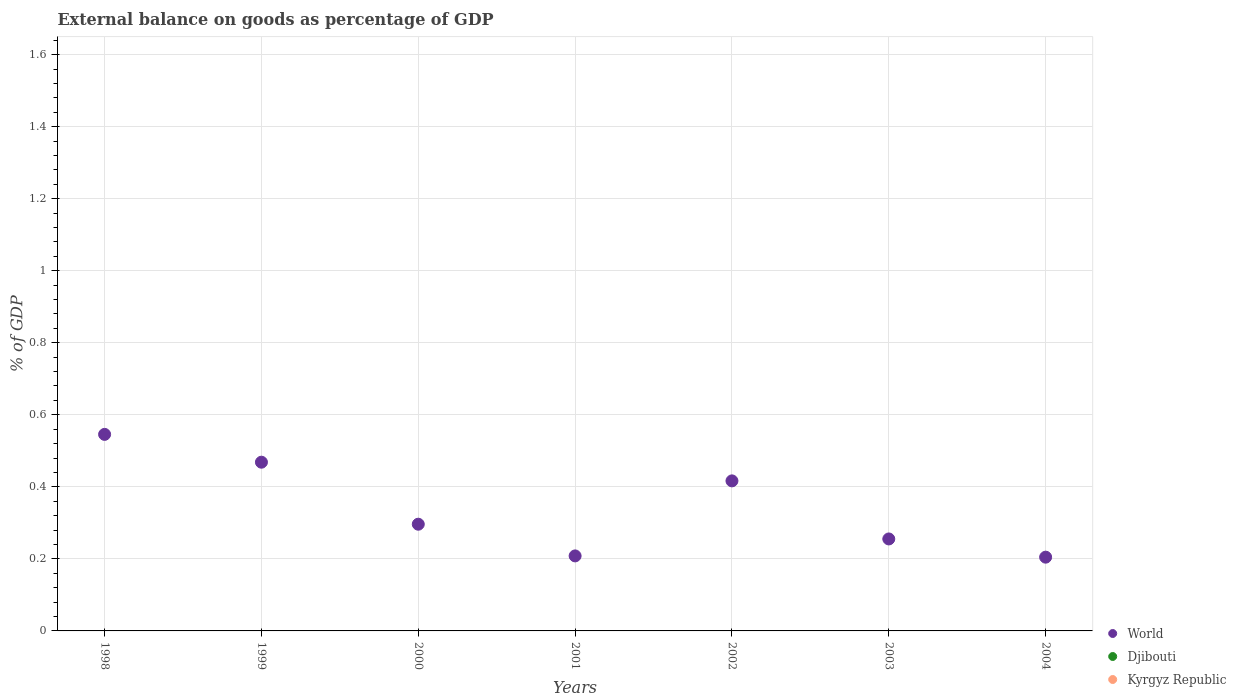How many different coloured dotlines are there?
Your answer should be very brief. 1. Is the number of dotlines equal to the number of legend labels?
Keep it short and to the point. No. What is the external balance on goods as percentage of GDP in World in 2003?
Your answer should be very brief. 0.26. Across all years, what is the maximum external balance on goods as percentage of GDP in World?
Give a very brief answer. 0.55. Across all years, what is the minimum external balance on goods as percentage of GDP in Kyrgyz Republic?
Provide a succinct answer. 0. What is the difference between the external balance on goods as percentage of GDP in World in 2002 and that in 2003?
Give a very brief answer. 0.16. What is the difference between the external balance on goods as percentage of GDP in Djibouti in 1998 and the external balance on goods as percentage of GDP in World in 2002?
Offer a very short reply. -0.42. What is the average external balance on goods as percentage of GDP in Kyrgyz Republic per year?
Provide a short and direct response. 0. In how many years, is the external balance on goods as percentage of GDP in World greater than 1.2400000000000002 %?
Offer a terse response. 0. What is the ratio of the external balance on goods as percentage of GDP in World in 1999 to that in 2003?
Give a very brief answer. 1.83. What is the difference between the highest and the second highest external balance on goods as percentage of GDP in World?
Ensure brevity in your answer.  0.08. What is the difference between the highest and the lowest external balance on goods as percentage of GDP in World?
Offer a terse response. 0.34. Is it the case that in every year, the sum of the external balance on goods as percentage of GDP in Djibouti and external balance on goods as percentage of GDP in World  is greater than the external balance on goods as percentage of GDP in Kyrgyz Republic?
Ensure brevity in your answer.  Yes. How many years are there in the graph?
Ensure brevity in your answer.  7. What is the difference between two consecutive major ticks on the Y-axis?
Your response must be concise. 0.2. Where does the legend appear in the graph?
Offer a very short reply. Bottom right. How many legend labels are there?
Your answer should be very brief. 3. What is the title of the graph?
Offer a terse response. External balance on goods as percentage of GDP. What is the label or title of the Y-axis?
Make the answer very short. % of GDP. What is the % of GDP of World in 1998?
Offer a very short reply. 0.55. What is the % of GDP in Djibouti in 1998?
Your answer should be very brief. 0. What is the % of GDP of Kyrgyz Republic in 1998?
Give a very brief answer. 0. What is the % of GDP of World in 1999?
Offer a terse response. 0.47. What is the % of GDP in Djibouti in 1999?
Your answer should be compact. 0. What is the % of GDP of Kyrgyz Republic in 1999?
Ensure brevity in your answer.  0. What is the % of GDP of World in 2000?
Make the answer very short. 0.3. What is the % of GDP in Djibouti in 2000?
Provide a short and direct response. 0. What is the % of GDP in Kyrgyz Republic in 2000?
Your response must be concise. 0. What is the % of GDP of World in 2001?
Make the answer very short. 0.21. What is the % of GDP of Djibouti in 2001?
Provide a short and direct response. 0. What is the % of GDP of World in 2002?
Offer a terse response. 0.42. What is the % of GDP in World in 2003?
Give a very brief answer. 0.26. What is the % of GDP in Kyrgyz Republic in 2003?
Give a very brief answer. 0. What is the % of GDP of World in 2004?
Make the answer very short. 0.2. What is the % of GDP of Djibouti in 2004?
Provide a succinct answer. 0. What is the % of GDP of Kyrgyz Republic in 2004?
Your answer should be compact. 0. Across all years, what is the maximum % of GDP in World?
Provide a short and direct response. 0.55. Across all years, what is the minimum % of GDP in World?
Provide a short and direct response. 0.2. What is the total % of GDP of World in the graph?
Your answer should be compact. 2.4. What is the difference between the % of GDP of World in 1998 and that in 1999?
Provide a succinct answer. 0.08. What is the difference between the % of GDP of World in 1998 and that in 2000?
Give a very brief answer. 0.25. What is the difference between the % of GDP of World in 1998 and that in 2001?
Offer a terse response. 0.34. What is the difference between the % of GDP of World in 1998 and that in 2002?
Your response must be concise. 0.13. What is the difference between the % of GDP of World in 1998 and that in 2003?
Offer a terse response. 0.29. What is the difference between the % of GDP in World in 1998 and that in 2004?
Provide a succinct answer. 0.34. What is the difference between the % of GDP of World in 1999 and that in 2000?
Offer a very short reply. 0.17. What is the difference between the % of GDP of World in 1999 and that in 2001?
Give a very brief answer. 0.26. What is the difference between the % of GDP in World in 1999 and that in 2002?
Provide a short and direct response. 0.05. What is the difference between the % of GDP of World in 1999 and that in 2003?
Provide a succinct answer. 0.21. What is the difference between the % of GDP in World in 1999 and that in 2004?
Your answer should be very brief. 0.26. What is the difference between the % of GDP of World in 2000 and that in 2001?
Offer a terse response. 0.09. What is the difference between the % of GDP of World in 2000 and that in 2002?
Provide a succinct answer. -0.12. What is the difference between the % of GDP of World in 2000 and that in 2003?
Provide a succinct answer. 0.04. What is the difference between the % of GDP of World in 2000 and that in 2004?
Your response must be concise. 0.09. What is the difference between the % of GDP in World in 2001 and that in 2002?
Provide a short and direct response. -0.21. What is the difference between the % of GDP in World in 2001 and that in 2003?
Offer a very short reply. -0.05. What is the difference between the % of GDP of World in 2001 and that in 2004?
Your response must be concise. 0. What is the difference between the % of GDP in World in 2002 and that in 2003?
Your answer should be compact. 0.16. What is the difference between the % of GDP in World in 2002 and that in 2004?
Provide a short and direct response. 0.21. What is the difference between the % of GDP in World in 2003 and that in 2004?
Offer a terse response. 0.05. What is the average % of GDP of World per year?
Keep it short and to the point. 0.34. What is the average % of GDP of Kyrgyz Republic per year?
Provide a succinct answer. 0. What is the ratio of the % of GDP of World in 1998 to that in 1999?
Provide a succinct answer. 1.16. What is the ratio of the % of GDP of World in 1998 to that in 2000?
Make the answer very short. 1.84. What is the ratio of the % of GDP in World in 1998 to that in 2001?
Your response must be concise. 2.62. What is the ratio of the % of GDP in World in 1998 to that in 2002?
Give a very brief answer. 1.31. What is the ratio of the % of GDP of World in 1998 to that in 2003?
Offer a very short reply. 2.14. What is the ratio of the % of GDP in World in 1998 to that in 2004?
Offer a very short reply. 2.66. What is the ratio of the % of GDP in World in 1999 to that in 2000?
Make the answer very short. 1.58. What is the ratio of the % of GDP in World in 1999 to that in 2001?
Make the answer very short. 2.25. What is the ratio of the % of GDP in World in 1999 to that in 2002?
Keep it short and to the point. 1.12. What is the ratio of the % of GDP in World in 1999 to that in 2003?
Ensure brevity in your answer.  1.83. What is the ratio of the % of GDP of World in 1999 to that in 2004?
Ensure brevity in your answer.  2.29. What is the ratio of the % of GDP in World in 2000 to that in 2001?
Your answer should be very brief. 1.42. What is the ratio of the % of GDP in World in 2000 to that in 2002?
Offer a very short reply. 0.71. What is the ratio of the % of GDP of World in 2000 to that in 2003?
Make the answer very short. 1.16. What is the ratio of the % of GDP of World in 2000 to that in 2004?
Your response must be concise. 1.45. What is the ratio of the % of GDP of World in 2001 to that in 2002?
Offer a very short reply. 0.5. What is the ratio of the % of GDP in World in 2001 to that in 2003?
Offer a terse response. 0.82. What is the ratio of the % of GDP in World in 2001 to that in 2004?
Keep it short and to the point. 1.02. What is the ratio of the % of GDP of World in 2002 to that in 2003?
Ensure brevity in your answer.  1.63. What is the ratio of the % of GDP of World in 2002 to that in 2004?
Your answer should be very brief. 2.03. What is the ratio of the % of GDP of World in 2003 to that in 2004?
Provide a succinct answer. 1.25. What is the difference between the highest and the second highest % of GDP of World?
Your answer should be very brief. 0.08. What is the difference between the highest and the lowest % of GDP in World?
Your answer should be compact. 0.34. 